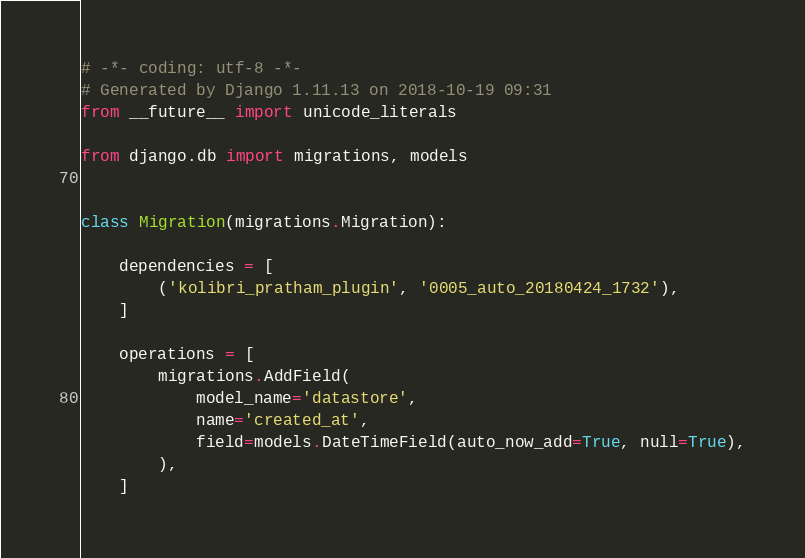<code> <loc_0><loc_0><loc_500><loc_500><_Python_># -*- coding: utf-8 -*-
# Generated by Django 1.11.13 on 2018-10-19 09:31
from __future__ import unicode_literals

from django.db import migrations, models


class Migration(migrations.Migration):

    dependencies = [
        ('kolibri_pratham_plugin', '0005_auto_20180424_1732'),
    ]

    operations = [
        migrations.AddField(
            model_name='datastore',
            name='created_at',
            field=models.DateTimeField(auto_now_add=True, null=True),
        ),
    ]
</code> 